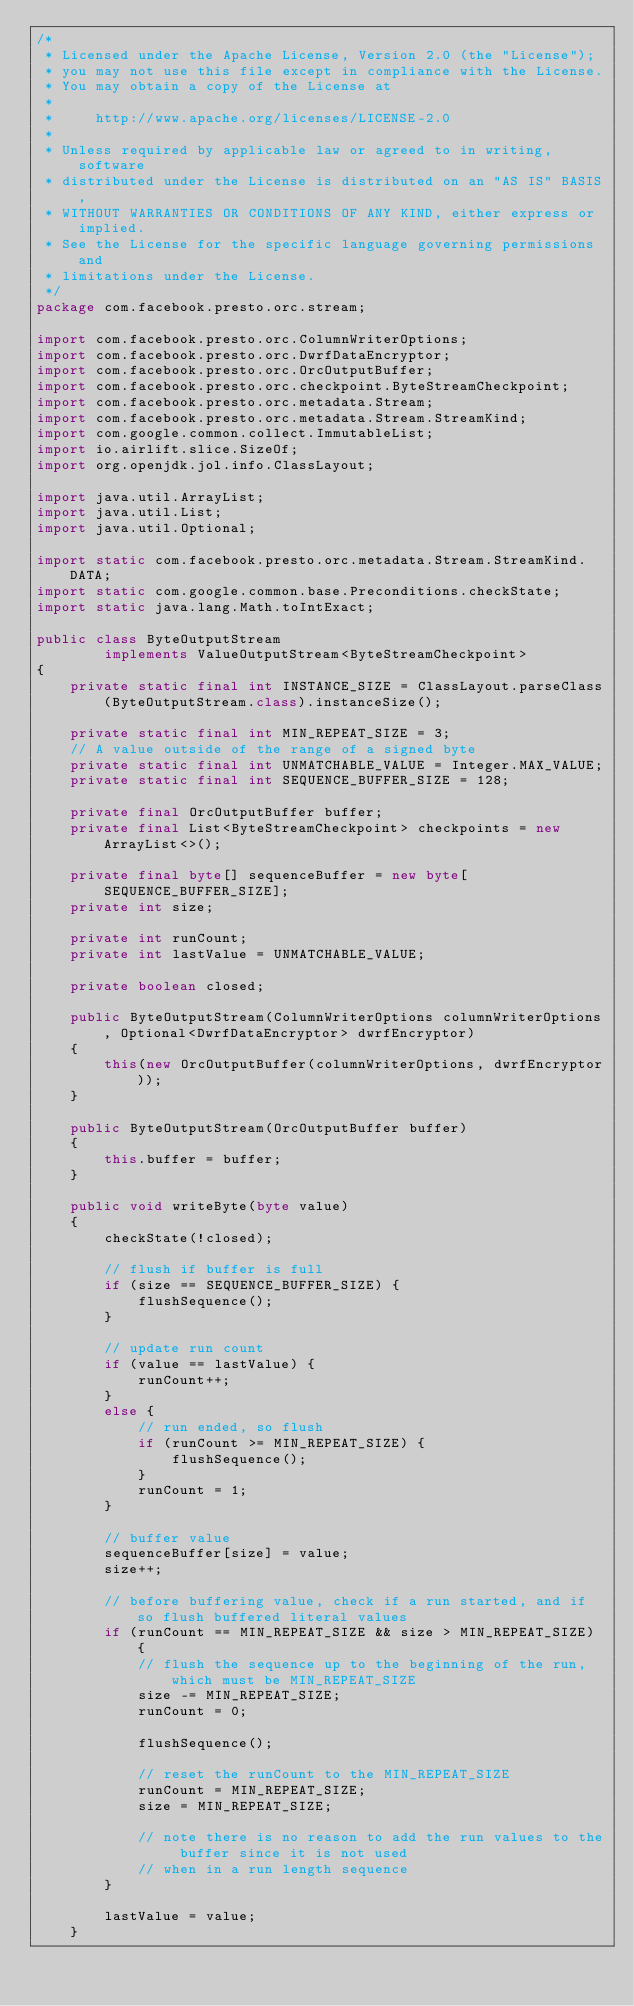Convert code to text. <code><loc_0><loc_0><loc_500><loc_500><_Java_>/*
 * Licensed under the Apache License, Version 2.0 (the "License");
 * you may not use this file except in compliance with the License.
 * You may obtain a copy of the License at
 *
 *     http://www.apache.org/licenses/LICENSE-2.0
 *
 * Unless required by applicable law or agreed to in writing, software
 * distributed under the License is distributed on an "AS IS" BASIS,
 * WITHOUT WARRANTIES OR CONDITIONS OF ANY KIND, either express or implied.
 * See the License for the specific language governing permissions and
 * limitations under the License.
 */
package com.facebook.presto.orc.stream;

import com.facebook.presto.orc.ColumnWriterOptions;
import com.facebook.presto.orc.DwrfDataEncryptor;
import com.facebook.presto.orc.OrcOutputBuffer;
import com.facebook.presto.orc.checkpoint.ByteStreamCheckpoint;
import com.facebook.presto.orc.metadata.Stream;
import com.facebook.presto.orc.metadata.Stream.StreamKind;
import com.google.common.collect.ImmutableList;
import io.airlift.slice.SizeOf;
import org.openjdk.jol.info.ClassLayout;

import java.util.ArrayList;
import java.util.List;
import java.util.Optional;

import static com.facebook.presto.orc.metadata.Stream.StreamKind.DATA;
import static com.google.common.base.Preconditions.checkState;
import static java.lang.Math.toIntExact;

public class ByteOutputStream
        implements ValueOutputStream<ByteStreamCheckpoint>
{
    private static final int INSTANCE_SIZE = ClassLayout.parseClass(ByteOutputStream.class).instanceSize();

    private static final int MIN_REPEAT_SIZE = 3;
    // A value outside of the range of a signed byte
    private static final int UNMATCHABLE_VALUE = Integer.MAX_VALUE;
    private static final int SEQUENCE_BUFFER_SIZE = 128;

    private final OrcOutputBuffer buffer;
    private final List<ByteStreamCheckpoint> checkpoints = new ArrayList<>();

    private final byte[] sequenceBuffer = new byte[SEQUENCE_BUFFER_SIZE];
    private int size;

    private int runCount;
    private int lastValue = UNMATCHABLE_VALUE;

    private boolean closed;

    public ByteOutputStream(ColumnWriterOptions columnWriterOptions, Optional<DwrfDataEncryptor> dwrfEncryptor)
    {
        this(new OrcOutputBuffer(columnWriterOptions, dwrfEncryptor));
    }

    public ByteOutputStream(OrcOutputBuffer buffer)
    {
        this.buffer = buffer;
    }

    public void writeByte(byte value)
    {
        checkState(!closed);

        // flush if buffer is full
        if (size == SEQUENCE_BUFFER_SIZE) {
            flushSequence();
        }

        // update run count
        if (value == lastValue) {
            runCount++;
        }
        else {
            // run ended, so flush
            if (runCount >= MIN_REPEAT_SIZE) {
                flushSequence();
            }
            runCount = 1;
        }

        // buffer value
        sequenceBuffer[size] = value;
        size++;

        // before buffering value, check if a run started, and if so flush buffered literal values
        if (runCount == MIN_REPEAT_SIZE && size > MIN_REPEAT_SIZE) {
            // flush the sequence up to the beginning of the run, which must be MIN_REPEAT_SIZE
            size -= MIN_REPEAT_SIZE;
            runCount = 0;

            flushSequence();

            // reset the runCount to the MIN_REPEAT_SIZE
            runCount = MIN_REPEAT_SIZE;
            size = MIN_REPEAT_SIZE;

            // note there is no reason to add the run values to the buffer since it is not used
            // when in a run length sequence
        }

        lastValue = value;
    }
</code> 